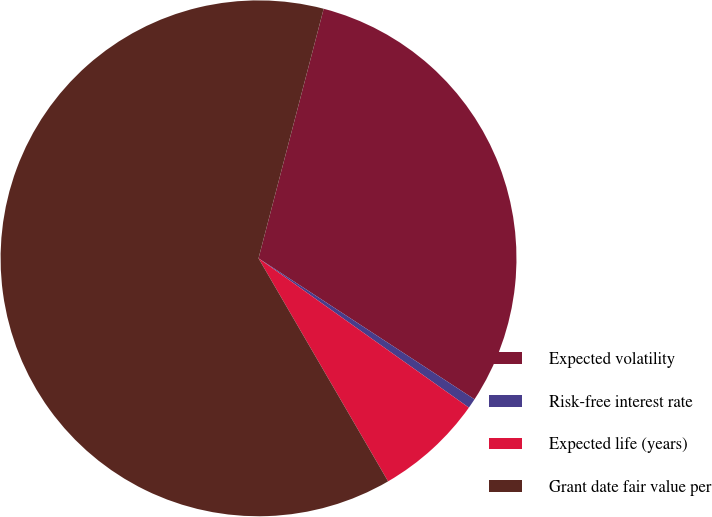Convert chart to OTSL. <chart><loc_0><loc_0><loc_500><loc_500><pie_chart><fcel>Expected volatility<fcel>Risk-free interest rate<fcel>Expected life (years)<fcel>Grant date fair value per<nl><fcel>30.14%<fcel>0.62%<fcel>6.8%<fcel>62.44%<nl></chart> 